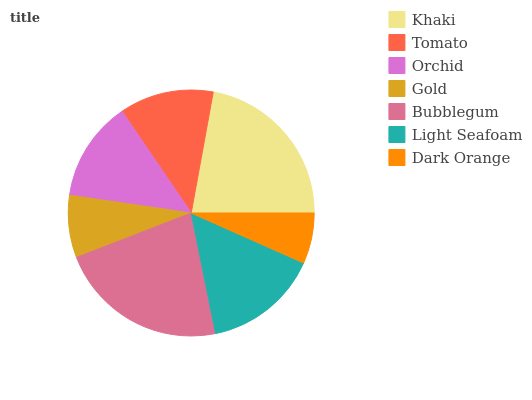Is Dark Orange the minimum?
Answer yes or no. Yes. Is Bubblegum the maximum?
Answer yes or no. Yes. Is Tomato the minimum?
Answer yes or no. No. Is Tomato the maximum?
Answer yes or no. No. Is Khaki greater than Tomato?
Answer yes or no. Yes. Is Tomato less than Khaki?
Answer yes or no. Yes. Is Tomato greater than Khaki?
Answer yes or no. No. Is Khaki less than Tomato?
Answer yes or no. No. Is Orchid the high median?
Answer yes or no. Yes. Is Orchid the low median?
Answer yes or no. Yes. Is Dark Orange the high median?
Answer yes or no. No. Is Tomato the low median?
Answer yes or no. No. 